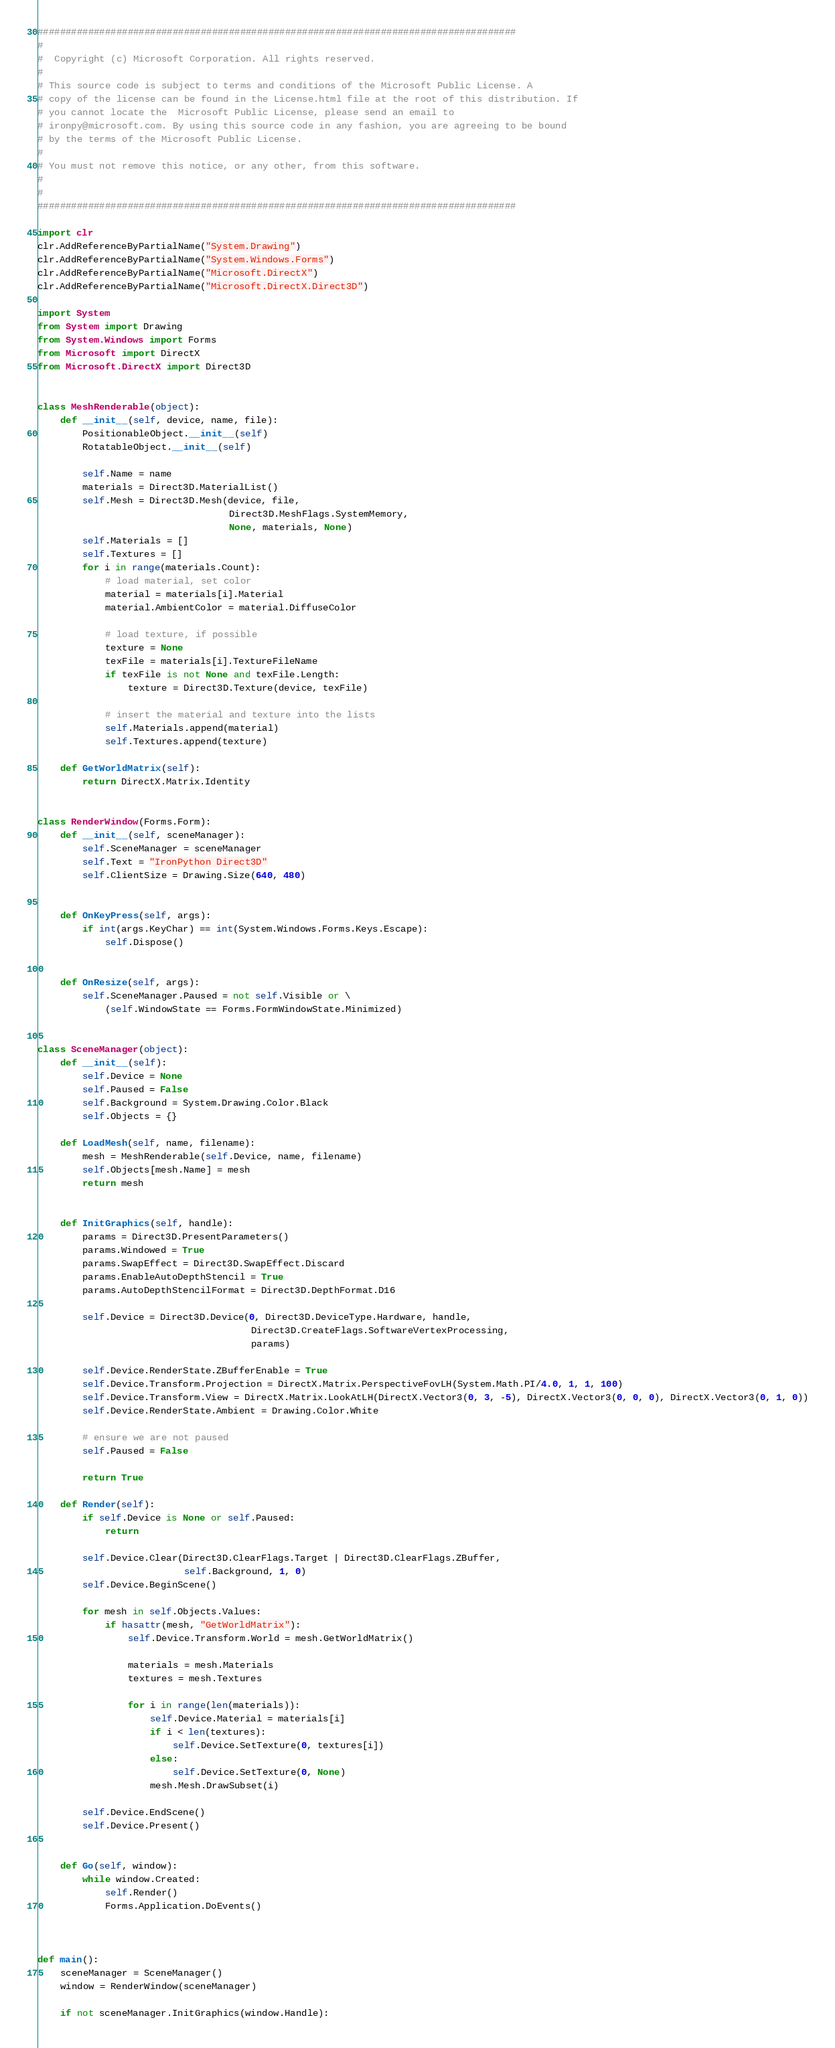<code> <loc_0><loc_0><loc_500><loc_500><_Python_>#####################################################################################
#
#  Copyright (c) Microsoft Corporation. All rights reserved.
#
# This source code is subject to terms and conditions of the Microsoft Public License. A 
# copy of the license can be found in the License.html file at the root of this distribution. If 
# you cannot locate the  Microsoft Public License, please send an email to 
# ironpy@microsoft.com. By using this source code in any fashion, you are agreeing to be bound 
# by the terms of the Microsoft Public License.
#
# You must not remove this notice, or any other, from this software.
#
#
#####################################################################################

import clr
clr.AddReferenceByPartialName("System.Drawing")
clr.AddReferenceByPartialName("System.Windows.Forms")
clr.AddReferenceByPartialName("Microsoft.DirectX")
clr.AddReferenceByPartialName("Microsoft.DirectX.Direct3D")

import System
from System import Drawing
from System.Windows import Forms
from Microsoft import DirectX
from Microsoft.DirectX import Direct3D


class MeshRenderable(object):
    def __init__(self, device, name, file):
        PositionableObject.__init__(self)
        RotatableObject.__init__(self)
        
        self.Name = name
        materials = Direct3D.MaterialList()
        self.Mesh = Direct3D.Mesh(device, file,
                                  Direct3D.MeshFlags.SystemMemory,
                                  None, materials, None)        
        self.Materials = []
        self.Textures = []
        for i in range(materials.Count):
            # load material, set color
            material = materials[i].Material
            material.AmbientColor = material.DiffuseColor
            
            # load texture, if possible
            texture = None
            texFile = materials[i].TextureFileName
            if texFile is not None and texFile.Length:
                texture = Direct3D.Texture(device, texFile)
            
            # insert the material and texture into the lists
            self.Materials.append(material)
            self.Textures.append(texture)
    
    def GetWorldMatrix(self):
        return DirectX.Matrix.Identity
        

class RenderWindow(Forms.Form):
    def __init__(self, sceneManager):
        self.SceneManager = sceneManager
        self.Text = "IronPython Direct3D"
        self.ClientSize = Drawing.Size(640, 480)
        

    def OnKeyPress(self, args):
        if int(args.KeyChar) == int(System.Windows.Forms.Keys.Escape):
            self.Dispose()
            

    def OnResize(self, args):
        self.SceneManager.Paused = not self.Visible or \
            (self.WindowState == Forms.FormWindowState.Minimized)


class SceneManager(object):
    def __init__(self):
        self.Device = None
        self.Paused = False
        self.Background = System.Drawing.Color.Black
        self.Objects = {}
        
    def LoadMesh(self, name, filename):
        mesh = MeshRenderable(self.Device, name, filename)
        self.Objects[mesh.Name] = mesh
        return mesh
        

    def InitGraphics(self, handle):
        params = Direct3D.PresentParameters()
        params.Windowed = True
        params.SwapEffect = Direct3D.SwapEffect.Discard
        params.EnableAutoDepthStencil = True
        params.AutoDepthStencilFormat = Direct3D.DepthFormat.D16

        self.Device = Direct3D.Device(0, Direct3D.DeviceType.Hardware, handle,
                                      Direct3D.CreateFlags.SoftwareVertexProcessing,
                                      params)

        self.Device.RenderState.ZBufferEnable = True
        self.Device.Transform.Projection = DirectX.Matrix.PerspectiveFovLH(System.Math.PI/4.0, 1, 1, 100)
        self.Device.Transform.View = DirectX.Matrix.LookAtLH(DirectX.Vector3(0, 3, -5), DirectX.Vector3(0, 0, 0), DirectX.Vector3(0, 1, 0))
        self.Device.RenderState.Ambient = Drawing.Color.White

        # ensure we are not paused
        self.Paused = False

        return True

    def Render(self):
        if self.Device is None or self.Paused:
            return
        
        self.Device.Clear(Direct3D.ClearFlags.Target | Direct3D.ClearFlags.ZBuffer,
                          self.Background, 1, 0)
        self.Device.BeginScene()

        for mesh in self.Objects.Values:
            if hasattr(mesh, "GetWorldMatrix"):
                self.Device.Transform.World = mesh.GetWorldMatrix()
                
                materials = mesh.Materials
                textures = mesh.Textures
                
                for i in range(len(materials)):
                    self.Device.Material = materials[i]
                    if i < len(textures):
                        self.Device.SetTexture(0, textures[i])
                    else:
                        self.Device.SetTexture(0, None)
                    mesh.Mesh.DrawSubset(i)

        self.Device.EndScene()
        self.Device.Present()


    def Go(self, window):
        while window.Created:
            self.Render()
            Forms.Application.DoEvents()
        


def main():
    sceneManager = SceneManager()
    window = RenderWindow(sceneManager)

    if not sceneManager.InitGraphics(window.Handle):</code> 